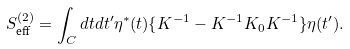Convert formula to latex. <formula><loc_0><loc_0><loc_500><loc_500>S _ { \text {eff} } ^ { ( 2 ) } = \int _ { C } d t d t ^ { \prime } \eta ^ { * } ( t ) \{ K ^ { - 1 } - K ^ { - 1 } K _ { 0 } K ^ { - 1 } \} \eta ( t ^ { \prime } ) .</formula> 